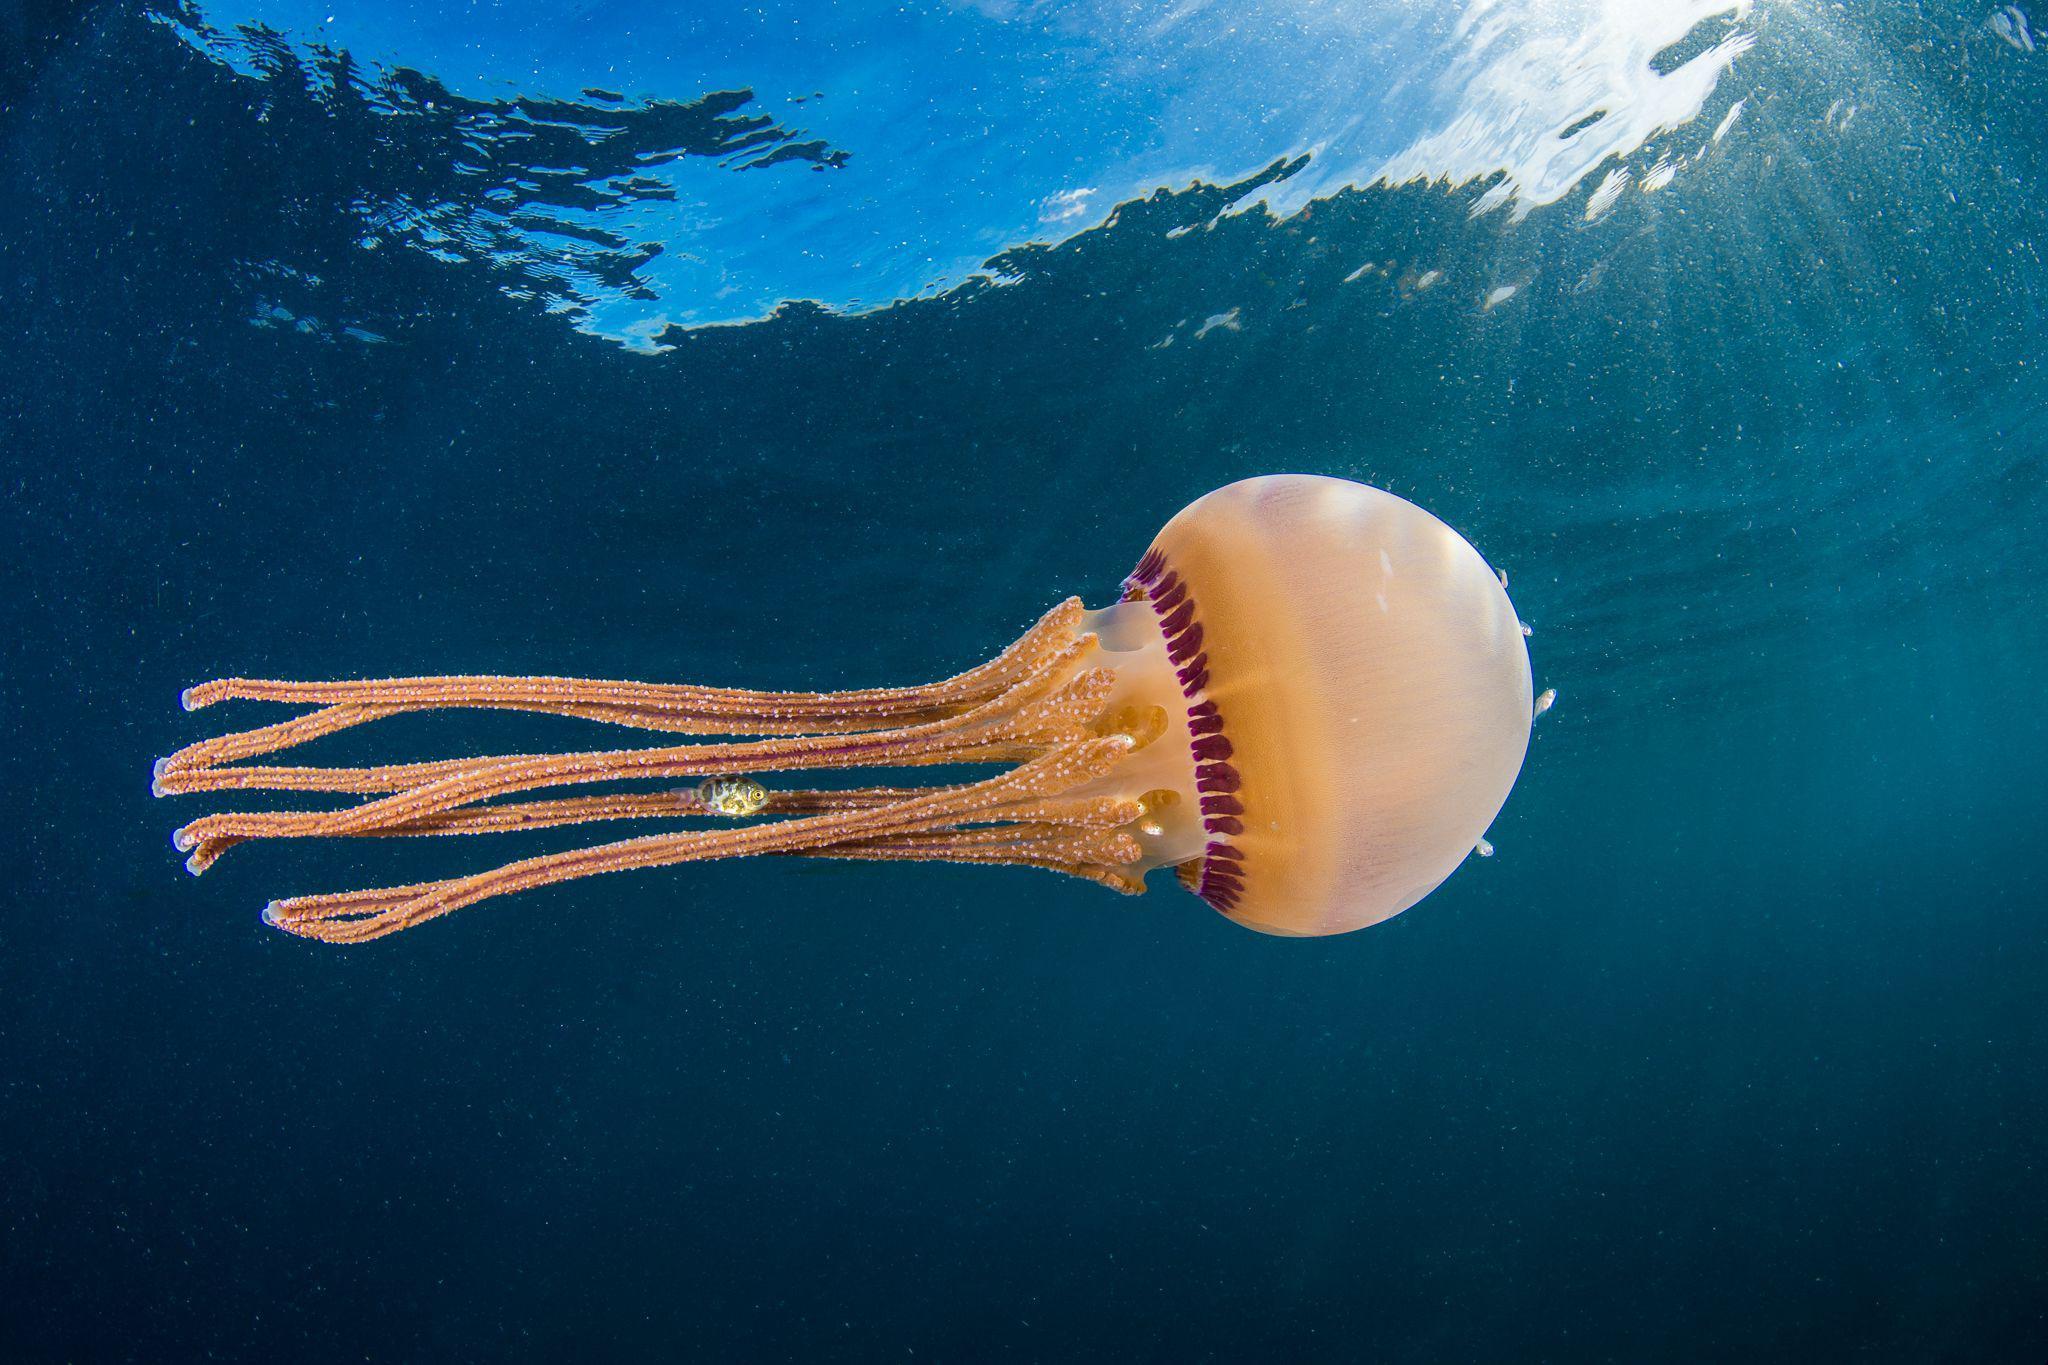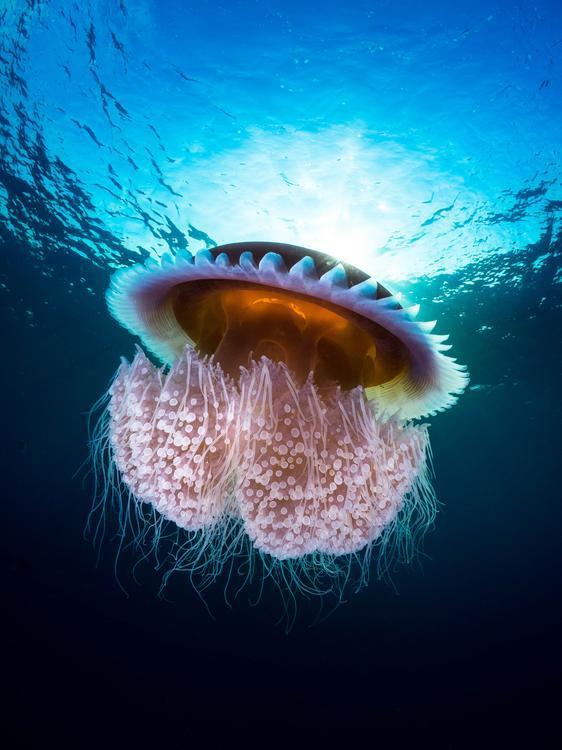The first image is the image on the left, the second image is the image on the right. Given the left and right images, does the statement "One image contains multiple jellyfish, and one image contains a single orange jellyfish with long 'ruffled' tendrils on a solid blue backdrop." hold true? Answer yes or no. No. The first image is the image on the left, the second image is the image on the right. Evaluate the accuracy of this statement regarding the images: "One jellyfish is swimming toward the right.". Is it true? Answer yes or no. Yes. 